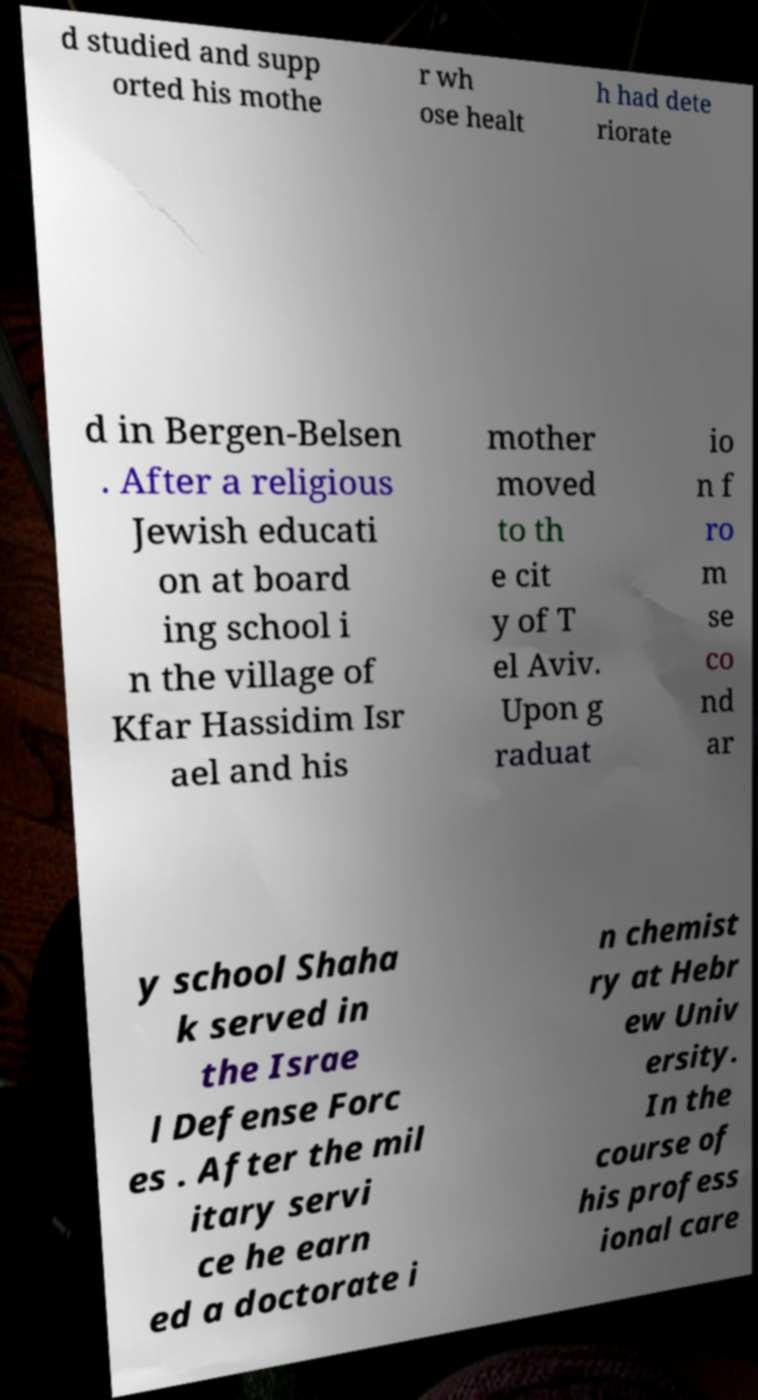Please read and relay the text visible in this image. What does it say? d studied and supp orted his mothe r wh ose healt h had dete riorate d in Bergen-Belsen . After a religious Jewish educati on at board ing school i n the village of Kfar Hassidim Isr ael and his mother moved to th e cit y of T el Aviv. Upon g raduat io n f ro m se co nd ar y school Shaha k served in the Israe l Defense Forc es . After the mil itary servi ce he earn ed a doctorate i n chemist ry at Hebr ew Univ ersity. In the course of his profess ional care 